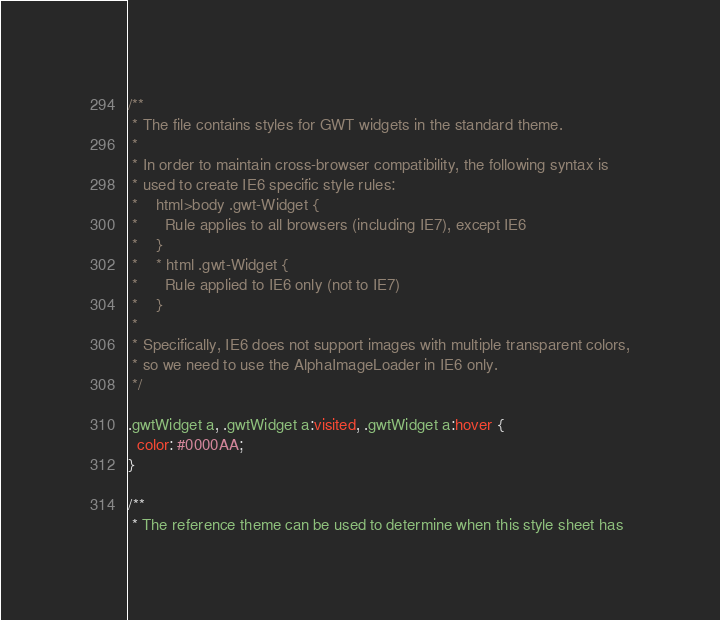Convert code to text. <code><loc_0><loc_0><loc_500><loc_500><_CSS_>/**
 * The file contains styles for GWT widgets in the standard theme.
 *
 * In order to maintain cross-browser compatibility, the following syntax is
 * used to create IE6 specific style rules:
 *    html>body .gwt-Widget {
 *      Rule applies to all browsers (including IE7), except IE6
 *    }
 *    * html .gwt-Widget {
 *      Rule applied to IE6 only (not to IE7)
 *    }
 * 
 * Specifically, IE6 does not support images with multiple transparent colors,
 * so we need to use the AlphaImageLoader in IE6 only.
 */

.gwtWidget a, .gwtWidget a:visited, .gwtWidget a:hover {
  color: #0000AA;
}

/**
 * The reference theme can be used to determine when this style sheet has</code> 